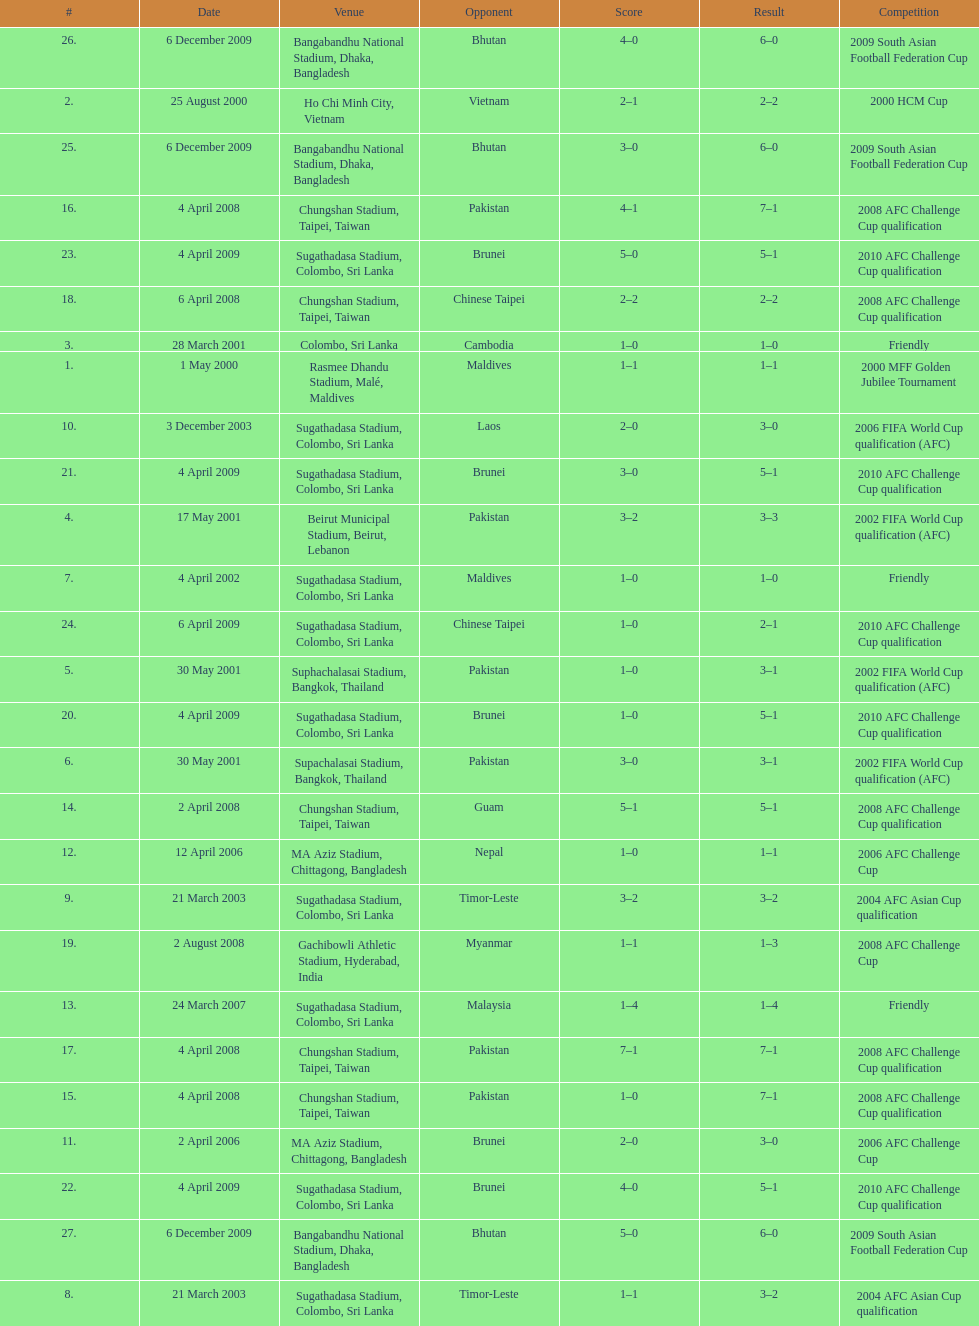Which venue has the largest result Chungshan Stadium, Taipei, Taiwan. 